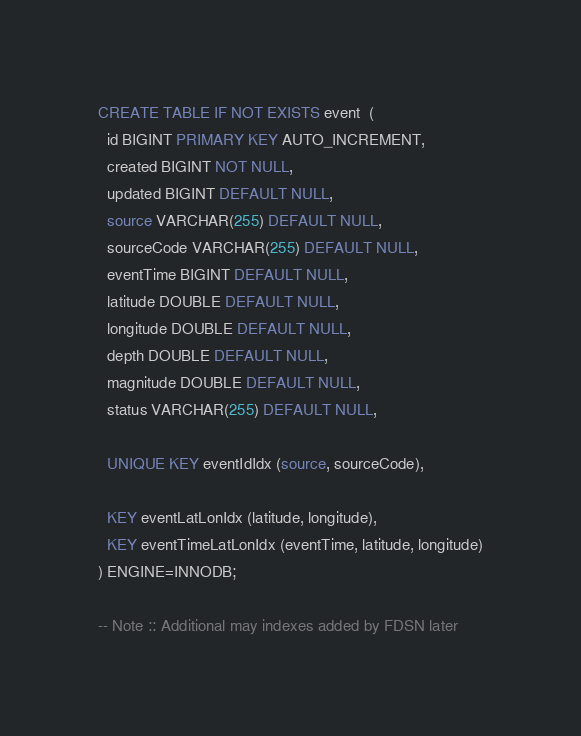Convert code to text. <code><loc_0><loc_0><loc_500><loc_500><_SQL_>CREATE TABLE IF NOT EXISTS event  (
  id BIGINT PRIMARY KEY AUTO_INCREMENT,
  created BIGINT NOT NULL,
  updated BIGINT DEFAULT NULL,
  source VARCHAR(255) DEFAULT NULL,
  sourceCode VARCHAR(255) DEFAULT NULL,
  eventTime BIGINT DEFAULT NULL,
  latitude DOUBLE DEFAULT NULL,
  longitude DOUBLE DEFAULT NULL,
  depth DOUBLE DEFAULT NULL,
  magnitude DOUBLE DEFAULT NULL,
  status VARCHAR(255) DEFAULT NULL,

  UNIQUE KEY eventIdIdx (source, sourceCode),

  KEY eventLatLonIdx (latitude, longitude),
  KEY eventTimeLatLonIdx (eventTime, latitude, longitude)
) ENGINE=INNODB;

-- Note :: Additional may indexes added by FDSN later</code> 